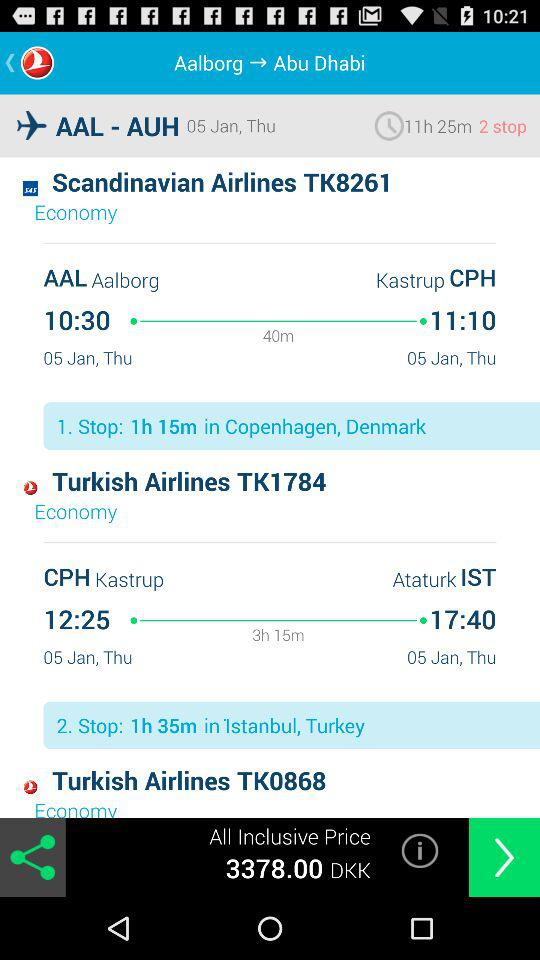What is the arrival time of "Scandinavian Airlines TK8261"? The arrival time is 11:10. 